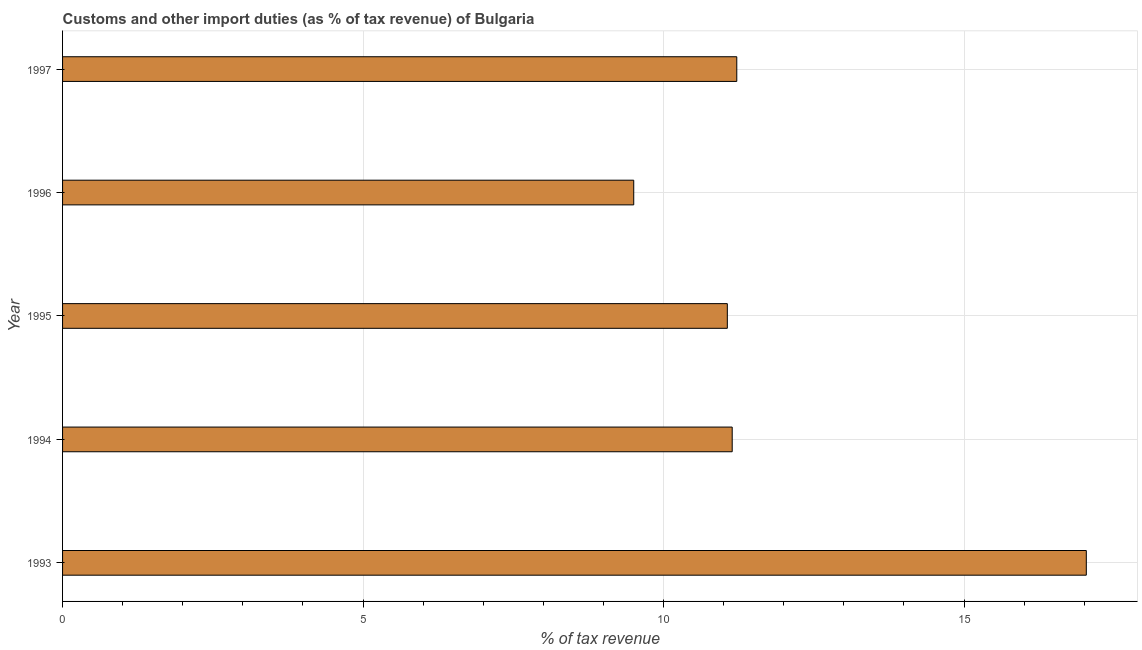Does the graph contain grids?
Provide a short and direct response. Yes. What is the title of the graph?
Make the answer very short. Customs and other import duties (as % of tax revenue) of Bulgaria. What is the label or title of the X-axis?
Offer a terse response. % of tax revenue. What is the customs and other import duties in 1995?
Provide a short and direct response. 11.06. Across all years, what is the maximum customs and other import duties?
Your answer should be compact. 17.03. Across all years, what is the minimum customs and other import duties?
Offer a very short reply. 9.5. In which year was the customs and other import duties minimum?
Your response must be concise. 1996. What is the sum of the customs and other import duties?
Your answer should be compact. 59.96. What is the difference between the customs and other import duties in 1993 and 1997?
Your answer should be very brief. 5.82. What is the average customs and other import duties per year?
Your answer should be compact. 11.99. What is the median customs and other import duties?
Offer a very short reply. 11.14. What is the ratio of the customs and other import duties in 1993 to that in 1997?
Your answer should be very brief. 1.52. Is the customs and other import duties in 1994 less than that in 1996?
Give a very brief answer. No. What is the difference between the highest and the second highest customs and other import duties?
Your response must be concise. 5.82. Is the sum of the customs and other import duties in 1994 and 1997 greater than the maximum customs and other import duties across all years?
Keep it short and to the point. Yes. What is the difference between the highest and the lowest customs and other import duties?
Give a very brief answer. 7.53. In how many years, is the customs and other import duties greater than the average customs and other import duties taken over all years?
Offer a terse response. 1. How many bars are there?
Ensure brevity in your answer.  5. Are the values on the major ticks of X-axis written in scientific E-notation?
Ensure brevity in your answer.  No. What is the % of tax revenue of 1993?
Your answer should be compact. 17.03. What is the % of tax revenue in 1994?
Ensure brevity in your answer.  11.14. What is the % of tax revenue of 1995?
Provide a short and direct response. 11.06. What is the % of tax revenue in 1996?
Your response must be concise. 9.5. What is the % of tax revenue in 1997?
Keep it short and to the point. 11.22. What is the difference between the % of tax revenue in 1993 and 1994?
Your answer should be compact. 5.89. What is the difference between the % of tax revenue in 1993 and 1995?
Your answer should be very brief. 5.97. What is the difference between the % of tax revenue in 1993 and 1996?
Give a very brief answer. 7.53. What is the difference between the % of tax revenue in 1993 and 1997?
Make the answer very short. 5.82. What is the difference between the % of tax revenue in 1994 and 1995?
Provide a short and direct response. 0.08. What is the difference between the % of tax revenue in 1994 and 1996?
Give a very brief answer. 1.64. What is the difference between the % of tax revenue in 1994 and 1997?
Your answer should be very brief. -0.08. What is the difference between the % of tax revenue in 1995 and 1996?
Make the answer very short. 1.56. What is the difference between the % of tax revenue in 1995 and 1997?
Keep it short and to the point. -0.16. What is the difference between the % of tax revenue in 1996 and 1997?
Keep it short and to the point. -1.71. What is the ratio of the % of tax revenue in 1993 to that in 1994?
Your answer should be compact. 1.53. What is the ratio of the % of tax revenue in 1993 to that in 1995?
Offer a very short reply. 1.54. What is the ratio of the % of tax revenue in 1993 to that in 1996?
Your response must be concise. 1.79. What is the ratio of the % of tax revenue in 1993 to that in 1997?
Give a very brief answer. 1.52. What is the ratio of the % of tax revenue in 1994 to that in 1995?
Provide a short and direct response. 1.01. What is the ratio of the % of tax revenue in 1994 to that in 1996?
Offer a very short reply. 1.17. What is the ratio of the % of tax revenue in 1994 to that in 1997?
Offer a very short reply. 0.99. What is the ratio of the % of tax revenue in 1995 to that in 1996?
Offer a terse response. 1.16. What is the ratio of the % of tax revenue in 1995 to that in 1997?
Your response must be concise. 0.99. What is the ratio of the % of tax revenue in 1996 to that in 1997?
Keep it short and to the point. 0.85. 